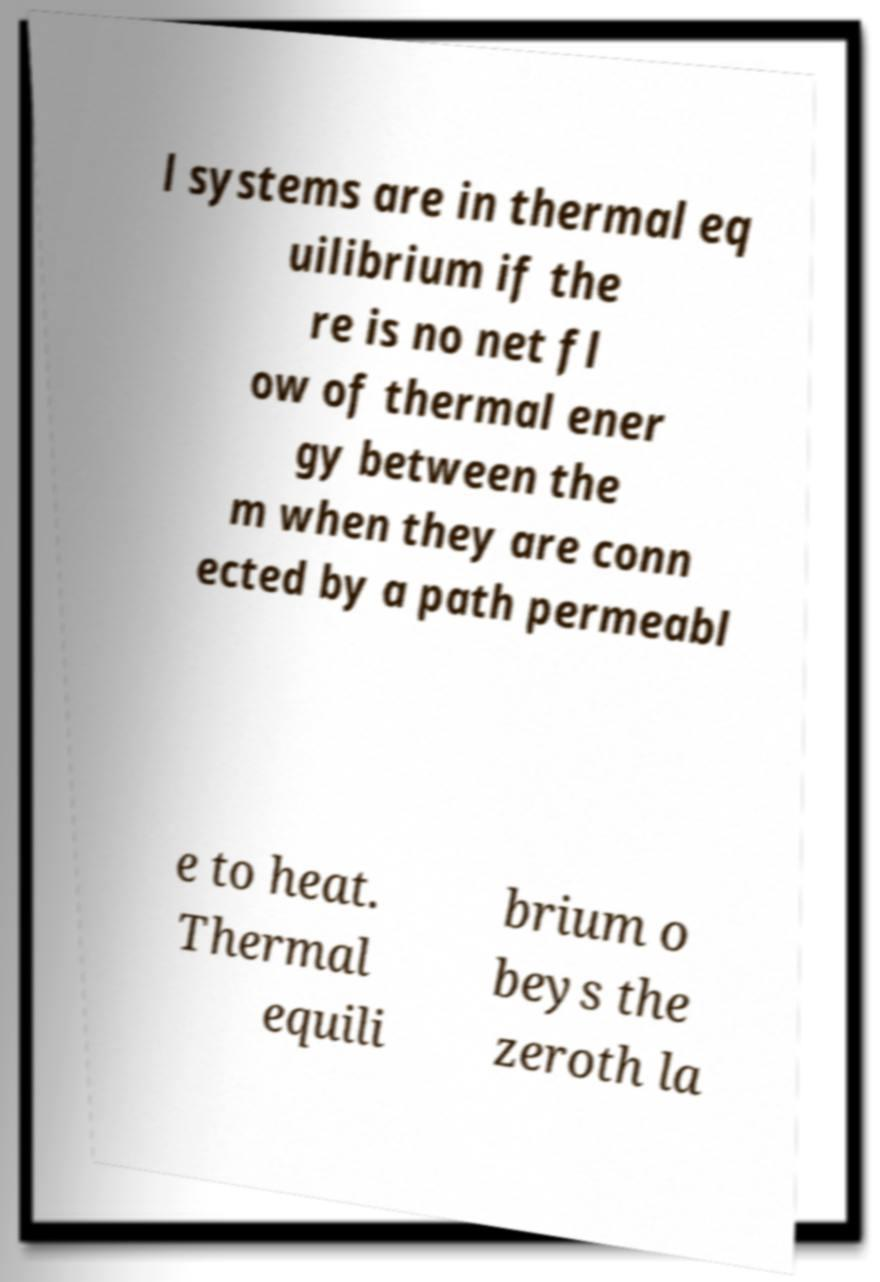Can you read and provide the text displayed in the image?This photo seems to have some interesting text. Can you extract and type it out for me? l systems are in thermal eq uilibrium if the re is no net fl ow of thermal ener gy between the m when they are conn ected by a path permeabl e to heat. Thermal equili brium o beys the zeroth la 